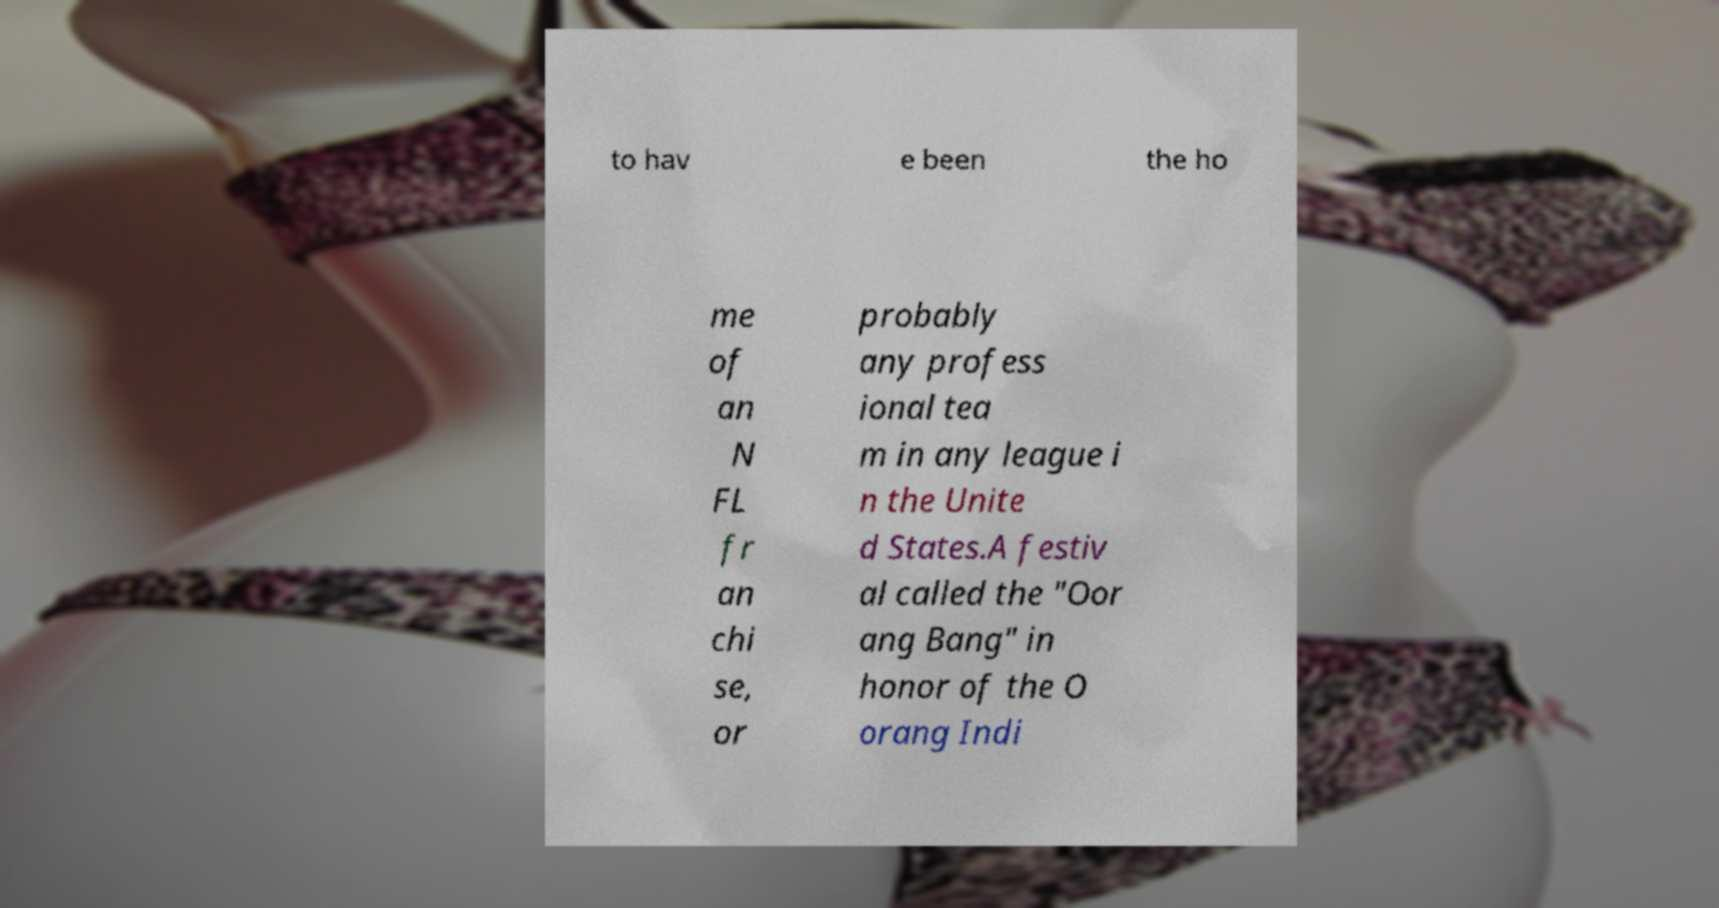Can you read and provide the text displayed in the image?This photo seems to have some interesting text. Can you extract and type it out for me? to hav e been the ho me of an N FL fr an chi se, or probably any profess ional tea m in any league i n the Unite d States.A festiv al called the "Oor ang Bang" in honor of the O orang Indi 